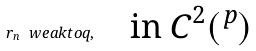<formula> <loc_0><loc_0><loc_500><loc_500>r _ { n } \ w e a k t o q , \quad \text {in $C^{2}(\real^{p})$}</formula> 